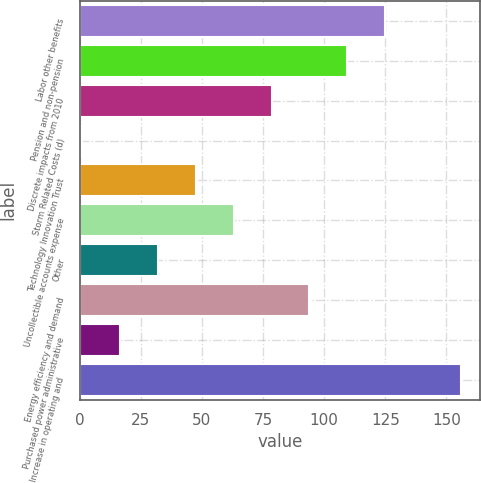Convert chart to OTSL. <chart><loc_0><loc_0><loc_500><loc_500><bar_chart><fcel>Labor other benefits<fcel>Pension and non-pension<fcel>Discrete impacts from 2010<fcel>Storm Related Costs (d)<fcel>Technology Innovation Trust<fcel>Uncollectible accounts expense<fcel>Other<fcel>Energy efficiency and demand<fcel>Purchased power administrative<fcel>Increase in operating and<nl><fcel>125<fcel>109.5<fcel>78.5<fcel>1<fcel>47.5<fcel>63<fcel>32<fcel>94<fcel>16.5<fcel>156<nl></chart> 